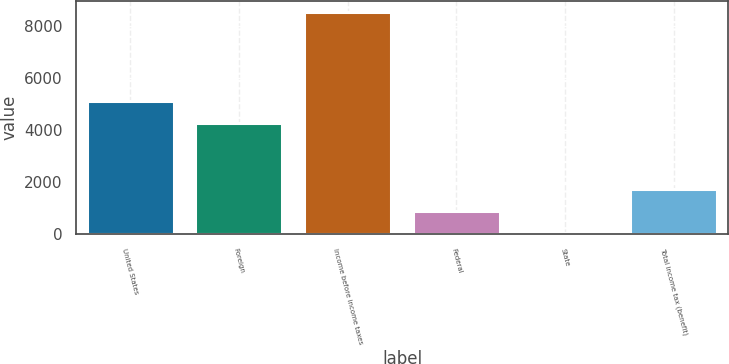Convert chart to OTSL. <chart><loc_0><loc_0><loc_500><loc_500><bar_chart><fcel>United States<fcel>Foreign<fcel>Income before income taxes<fcel>Federal<fcel>State<fcel>Total income tax (benefit)<nl><fcel>5112.5<fcel>4263<fcel>8530<fcel>884.5<fcel>35<fcel>1734<nl></chart> 